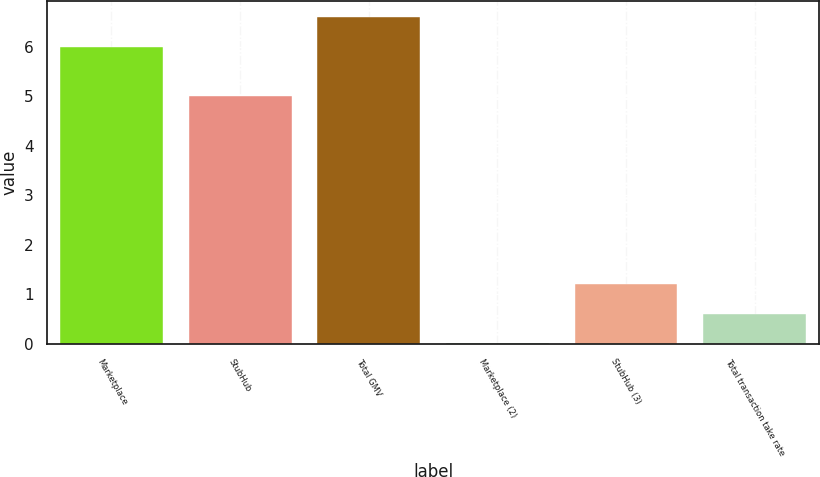<chart> <loc_0><loc_0><loc_500><loc_500><bar_chart><fcel>Marketplace<fcel>StubHub<fcel>Total GMV<fcel>Marketplace (2)<fcel>StubHub (3)<fcel>Total transaction take rate<nl><fcel>6<fcel>5<fcel>6.6<fcel>0.01<fcel>1.21<fcel>0.61<nl></chart> 